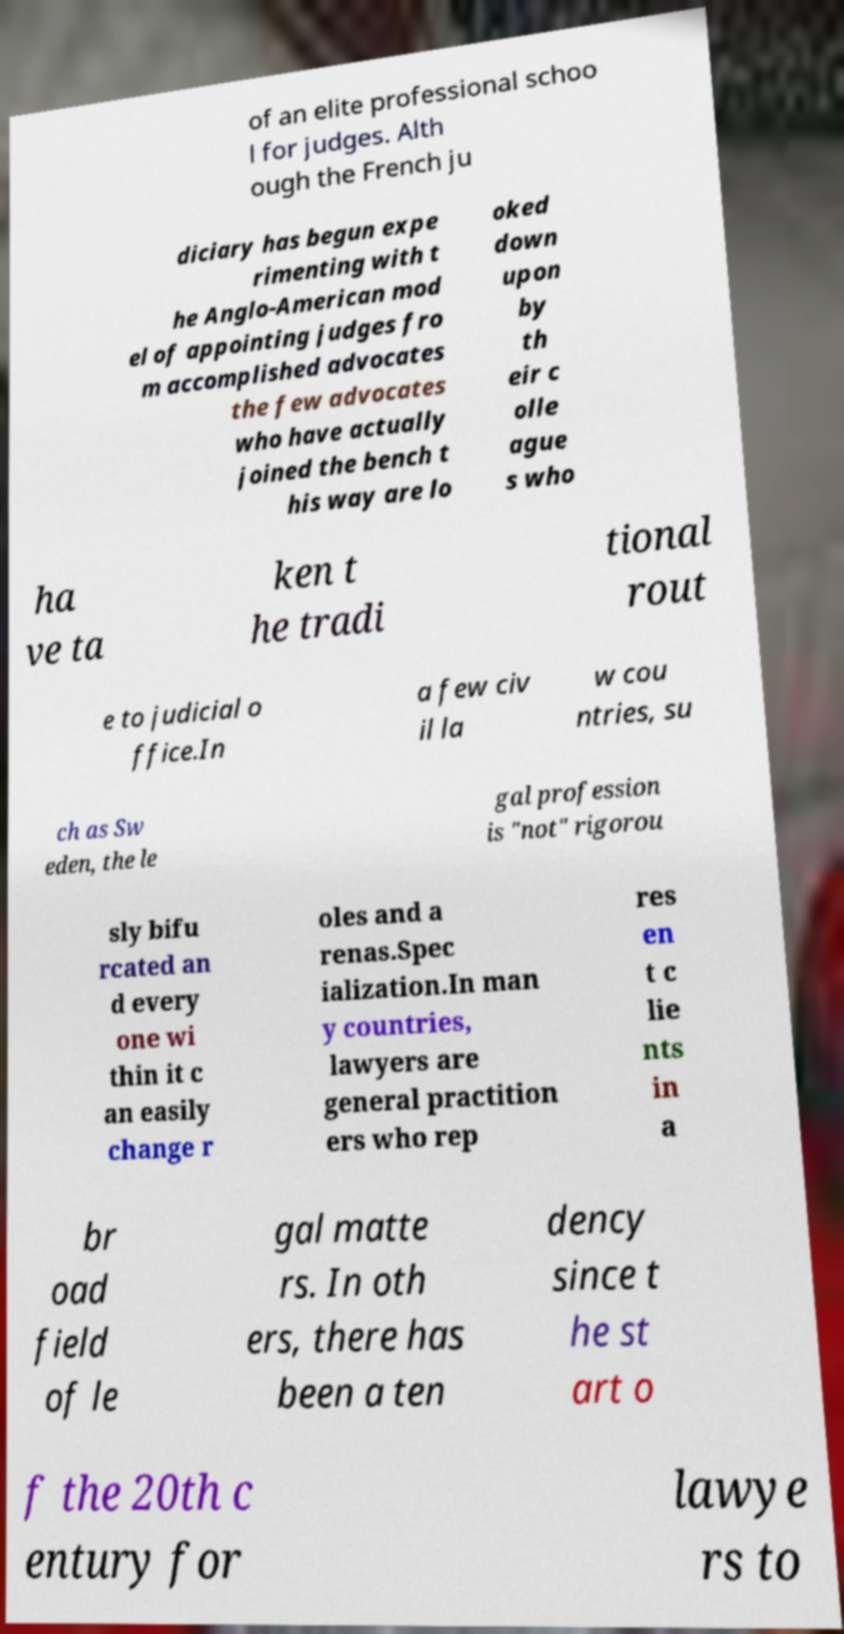Please read and relay the text visible in this image. What does it say? of an elite professional schoo l for judges. Alth ough the French ju diciary has begun expe rimenting with t he Anglo-American mod el of appointing judges fro m accomplished advocates the few advocates who have actually joined the bench t his way are lo oked down upon by th eir c olle ague s who ha ve ta ken t he tradi tional rout e to judicial o ffice.In a few civ il la w cou ntries, su ch as Sw eden, the le gal profession is "not" rigorou sly bifu rcated an d every one wi thin it c an easily change r oles and a renas.Spec ialization.In man y countries, lawyers are general practition ers who rep res en t c lie nts in a br oad field of le gal matte rs. In oth ers, there has been a ten dency since t he st art o f the 20th c entury for lawye rs to 